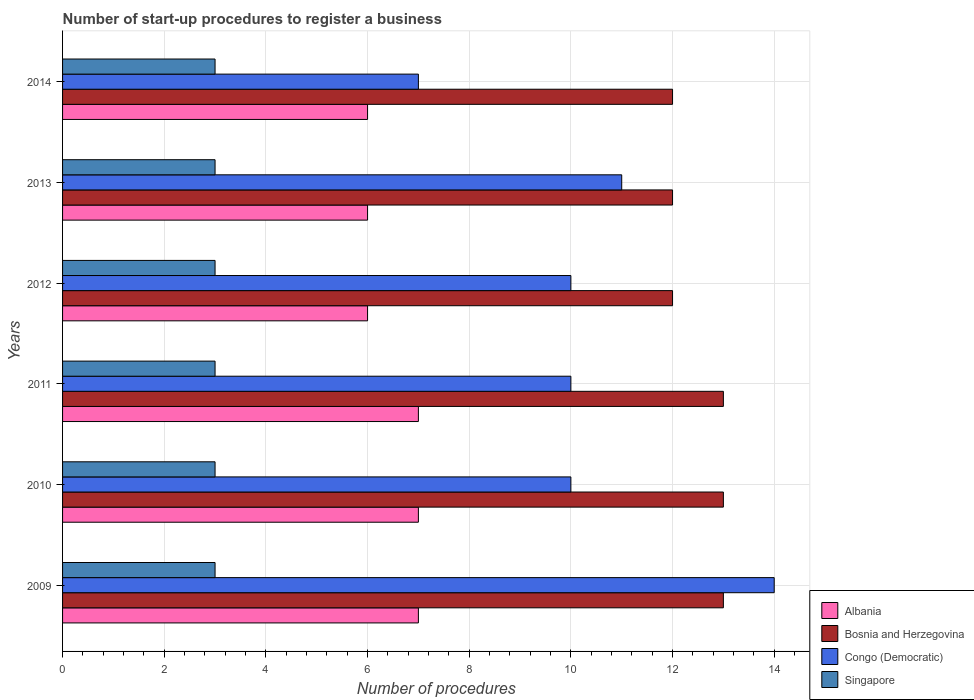How many groups of bars are there?
Provide a succinct answer. 6. Are the number of bars per tick equal to the number of legend labels?
Offer a very short reply. Yes. Are the number of bars on each tick of the Y-axis equal?
Offer a terse response. Yes. What is the number of procedures required to register a business in Bosnia and Herzegovina in 2014?
Offer a very short reply. 12. Across all years, what is the maximum number of procedures required to register a business in Congo (Democratic)?
Provide a short and direct response. 14. Across all years, what is the minimum number of procedures required to register a business in Bosnia and Herzegovina?
Give a very brief answer. 12. In which year was the number of procedures required to register a business in Congo (Democratic) maximum?
Make the answer very short. 2009. What is the total number of procedures required to register a business in Albania in the graph?
Ensure brevity in your answer.  39. What is the difference between the number of procedures required to register a business in Bosnia and Herzegovina in 2010 and the number of procedures required to register a business in Albania in 2012?
Keep it short and to the point. 7. What is the average number of procedures required to register a business in Bosnia and Herzegovina per year?
Provide a short and direct response. 12.5. In the year 2012, what is the difference between the number of procedures required to register a business in Bosnia and Herzegovina and number of procedures required to register a business in Congo (Democratic)?
Your answer should be very brief. 2. What is the ratio of the number of procedures required to register a business in Bosnia and Herzegovina in 2011 to that in 2012?
Give a very brief answer. 1.08. Is the number of procedures required to register a business in Singapore in 2011 less than that in 2013?
Ensure brevity in your answer.  No. Is the difference between the number of procedures required to register a business in Bosnia and Herzegovina in 2009 and 2013 greater than the difference between the number of procedures required to register a business in Congo (Democratic) in 2009 and 2013?
Your answer should be very brief. No. What is the difference between the highest and the second highest number of procedures required to register a business in Singapore?
Provide a short and direct response. 0. What is the difference between the highest and the lowest number of procedures required to register a business in Albania?
Make the answer very short. 1. What does the 3rd bar from the top in 2014 represents?
Provide a succinct answer. Bosnia and Herzegovina. What does the 1st bar from the bottom in 2014 represents?
Offer a very short reply. Albania. Is it the case that in every year, the sum of the number of procedures required to register a business in Bosnia and Herzegovina and number of procedures required to register a business in Singapore is greater than the number of procedures required to register a business in Congo (Democratic)?
Your answer should be very brief. Yes. Are all the bars in the graph horizontal?
Provide a succinct answer. Yes. Are the values on the major ticks of X-axis written in scientific E-notation?
Provide a succinct answer. No. Does the graph contain grids?
Make the answer very short. Yes. How many legend labels are there?
Give a very brief answer. 4. What is the title of the graph?
Ensure brevity in your answer.  Number of start-up procedures to register a business. Does "Puerto Rico" appear as one of the legend labels in the graph?
Offer a very short reply. No. What is the label or title of the X-axis?
Give a very brief answer. Number of procedures. What is the label or title of the Y-axis?
Offer a terse response. Years. What is the Number of procedures in Albania in 2009?
Keep it short and to the point. 7. What is the Number of procedures in Bosnia and Herzegovina in 2009?
Keep it short and to the point. 13. What is the Number of procedures in Singapore in 2009?
Your response must be concise. 3. What is the Number of procedures in Albania in 2010?
Your answer should be very brief. 7. What is the Number of procedures of Congo (Democratic) in 2010?
Provide a short and direct response. 10. What is the Number of procedures of Singapore in 2010?
Your answer should be compact. 3. What is the Number of procedures in Albania in 2012?
Keep it short and to the point. 6. What is the Number of procedures in Singapore in 2012?
Offer a very short reply. 3. What is the Number of procedures in Albania in 2013?
Provide a succinct answer. 6. What is the Number of procedures in Congo (Democratic) in 2013?
Give a very brief answer. 11. What is the Number of procedures in Singapore in 2013?
Your response must be concise. 3. What is the Number of procedures in Singapore in 2014?
Offer a terse response. 3. Across all years, what is the maximum Number of procedures in Albania?
Keep it short and to the point. 7. Across all years, what is the maximum Number of procedures in Bosnia and Herzegovina?
Your answer should be very brief. 13. Across all years, what is the maximum Number of procedures of Congo (Democratic)?
Your answer should be compact. 14. Across all years, what is the minimum Number of procedures of Congo (Democratic)?
Give a very brief answer. 7. What is the total Number of procedures of Albania in the graph?
Make the answer very short. 39. What is the total Number of procedures of Bosnia and Herzegovina in the graph?
Provide a succinct answer. 75. What is the difference between the Number of procedures in Albania in 2009 and that in 2010?
Ensure brevity in your answer.  0. What is the difference between the Number of procedures in Congo (Democratic) in 2009 and that in 2010?
Make the answer very short. 4. What is the difference between the Number of procedures in Singapore in 2009 and that in 2010?
Offer a terse response. 0. What is the difference between the Number of procedures of Bosnia and Herzegovina in 2009 and that in 2011?
Provide a short and direct response. 0. What is the difference between the Number of procedures of Singapore in 2009 and that in 2011?
Offer a terse response. 0. What is the difference between the Number of procedures in Albania in 2009 and that in 2012?
Make the answer very short. 1. What is the difference between the Number of procedures in Congo (Democratic) in 2009 and that in 2013?
Make the answer very short. 3. What is the difference between the Number of procedures of Singapore in 2009 and that in 2013?
Your answer should be very brief. 0. What is the difference between the Number of procedures of Congo (Democratic) in 2009 and that in 2014?
Offer a terse response. 7. What is the difference between the Number of procedures of Singapore in 2009 and that in 2014?
Offer a terse response. 0. What is the difference between the Number of procedures in Albania in 2010 and that in 2011?
Ensure brevity in your answer.  0. What is the difference between the Number of procedures of Congo (Democratic) in 2010 and that in 2011?
Offer a very short reply. 0. What is the difference between the Number of procedures in Singapore in 2010 and that in 2011?
Ensure brevity in your answer.  0. What is the difference between the Number of procedures in Bosnia and Herzegovina in 2010 and that in 2012?
Give a very brief answer. 1. What is the difference between the Number of procedures in Albania in 2010 and that in 2013?
Provide a succinct answer. 1. What is the difference between the Number of procedures of Bosnia and Herzegovina in 2010 and that in 2013?
Your answer should be compact. 1. What is the difference between the Number of procedures of Albania in 2010 and that in 2014?
Offer a very short reply. 1. What is the difference between the Number of procedures of Bosnia and Herzegovina in 2010 and that in 2014?
Provide a succinct answer. 1. What is the difference between the Number of procedures in Singapore in 2010 and that in 2014?
Offer a terse response. 0. What is the difference between the Number of procedures in Bosnia and Herzegovina in 2011 and that in 2012?
Ensure brevity in your answer.  1. What is the difference between the Number of procedures of Congo (Democratic) in 2011 and that in 2012?
Keep it short and to the point. 0. What is the difference between the Number of procedures in Singapore in 2011 and that in 2012?
Keep it short and to the point. 0. What is the difference between the Number of procedures of Bosnia and Herzegovina in 2011 and that in 2013?
Offer a terse response. 1. What is the difference between the Number of procedures in Singapore in 2011 and that in 2013?
Give a very brief answer. 0. What is the difference between the Number of procedures of Albania in 2011 and that in 2014?
Your answer should be very brief. 1. What is the difference between the Number of procedures of Singapore in 2011 and that in 2014?
Make the answer very short. 0. What is the difference between the Number of procedures of Bosnia and Herzegovina in 2012 and that in 2013?
Make the answer very short. 0. What is the difference between the Number of procedures in Congo (Democratic) in 2012 and that in 2013?
Your response must be concise. -1. What is the difference between the Number of procedures of Singapore in 2012 and that in 2013?
Offer a terse response. 0. What is the difference between the Number of procedures of Albania in 2012 and that in 2014?
Your answer should be very brief. 0. What is the difference between the Number of procedures of Bosnia and Herzegovina in 2013 and that in 2014?
Provide a succinct answer. 0. What is the difference between the Number of procedures in Singapore in 2013 and that in 2014?
Your answer should be compact. 0. What is the difference between the Number of procedures of Albania in 2009 and the Number of procedures of Bosnia and Herzegovina in 2010?
Your response must be concise. -6. What is the difference between the Number of procedures in Bosnia and Herzegovina in 2009 and the Number of procedures in Congo (Democratic) in 2010?
Offer a very short reply. 3. What is the difference between the Number of procedures in Bosnia and Herzegovina in 2009 and the Number of procedures in Singapore in 2010?
Your response must be concise. 10. What is the difference between the Number of procedures of Congo (Democratic) in 2009 and the Number of procedures of Singapore in 2010?
Offer a very short reply. 11. What is the difference between the Number of procedures of Albania in 2009 and the Number of procedures of Bosnia and Herzegovina in 2011?
Give a very brief answer. -6. What is the difference between the Number of procedures in Bosnia and Herzegovina in 2009 and the Number of procedures in Congo (Democratic) in 2011?
Offer a very short reply. 3. What is the difference between the Number of procedures of Albania in 2009 and the Number of procedures of Singapore in 2012?
Offer a very short reply. 4. What is the difference between the Number of procedures of Bosnia and Herzegovina in 2009 and the Number of procedures of Congo (Democratic) in 2012?
Ensure brevity in your answer.  3. What is the difference between the Number of procedures in Congo (Democratic) in 2009 and the Number of procedures in Singapore in 2012?
Make the answer very short. 11. What is the difference between the Number of procedures of Albania in 2009 and the Number of procedures of Bosnia and Herzegovina in 2013?
Provide a short and direct response. -5. What is the difference between the Number of procedures of Albania in 2009 and the Number of procedures of Singapore in 2013?
Offer a terse response. 4. What is the difference between the Number of procedures in Bosnia and Herzegovina in 2009 and the Number of procedures in Singapore in 2013?
Keep it short and to the point. 10. What is the difference between the Number of procedures in Albania in 2009 and the Number of procedures in Bosnia and Herzegovina in 2014?
Your answer should be very brief. -5. What is the difference between the Number of procedures of Albania in 2009 and the Number of procedures of Congo (Democratic) in 2014?
Make the answer very short. 0. What is the difference between the Number of procedures in Albania in 2009 and the Number of procedures in Singapore in 2014?
Ensure brevity in your answer.  4. What is the difference between the Number of procedures of Albania in 2010 and the Number of procedures of Bosnia and Herzegovina in 2011?
Keep it short and to the point. -6. What is the difference between the Number of procedures of Albania in 2010 and the Number of procedures of Congo (Democratic) in 2011?
Your answer should be very brief. -3. What is the difference between the Number of procedures of Congo (Democratic) in 2010 and the Number of procedures of Singapore in 2011?
Offer a very short reply. 7. What is the difference between the Number of procedures of Albania in 2010 and the Number of procedures of Singapore in 2012?
Give a very brief answer. 4. What is the difference between the Number of procedures of Bosnia and Herzegovina in 2010 and the Number of procedures of Congo (Democratic) in 2012?
Your answer should be very brief. 3. What is the difference between the Number of procedures of Bosnia and Herzegovina in 2010 and the Number of procedures of Singapore in 2012?
Your response must be concise. 10. What is the difference between the Number of procedures of Congo (Democratic) in 2010 and the Number of procedures of Singapore in 2012?
Your answer should be very brief. 7. What is the difference between the Number of procedures in Albania in 2010 and the Number of procedures in Congo (Democratic) in 2013?
Provide a succinct answer. -4. What is the difference between the Number of procedures in Albania in 2010 and the Number of procedures in Singapore in 2013?
Keep it short and to the point. 4. What is the difference between the Number of procedures in Bosnia and Herzegovina in 2010 and the Number of procedures in Congo (Democratic) in 2013?
Make the answer very short. 2. What is the difference between the Number of procedures of Albania in 2010 and the Number of procedures of Singapore in 2014?
Your answer should be very brief. 4. What is the difference between the Number of procedures of Bosnia and Herzegovina in 2010 and the Number of procedures of Congo (Democratic) in 2014?
Make the answer very short. 6. What is the difference between the Number of procedures in Congo (Democratic) in 2010 and the Number of procedures in Singapore in 2014?
Make the answer very short. 7. What is the difference between the Number of procedures of Albania in 2011 and the Number of procedures of Congo (Democratic) in 2012?
Give a very brief answer. -3. What is the difference between the Number of procedures of Bosnia and Herzegovina in 2011 and the Number of procedures of Congo (Democratic) in 2012?
Keep it short and to the point. 3. What is the difference between the Number of procedures of Albania in 2011 and the Number of procedures of Singapore in 2013?
Offer a terse response. 4. What is the difference between the Number of procedures of Albania in 2011 and the Number of procedures of Bosnia and Herzegovina in 2014?
Keep it short and to the point. -5. What is the difference between the Number of procedures of Bosnia and Herzegovina in 2011 and the Number of procedures of Singapore in 2014?
Your response must be concise. 10. What is the difference between the Number of procedures of Congo (Democratic) in 2011 and the Number of procedures of Singapore in 2014?
Your response must be concise. 7. What is the difference between the Number of procedures in Albania in 2012 and the Number of procedures in Bosnia and Herzegovina in 2013?
Ensure brevity in your answer.  -6. What is the difference between the Number of procedures of Albania in 2012 and the Number of procedures of Congo (Democratic) in 2013?
Keep it short and to the point. -5. What is the difference between the Number of procedures of Albania in 2012 and the Number of procedures of Singapore in 2013?
Keep it short and to the point. 3. What is the difference between the Number of procedures in Bosnia and Herzegovina in 2012 and the Number of procedures in Congo (Democratic) in 2013?
Your answer should be very brief. 1. What is the difference between the Number of procedures in Albania in 2012 and the Number of procedures in Bosnia and Herzegovina in 2014?
Offer a terse response. -6. What is the difference between the Number of procedures in Albania in 2012 and the Number of procedures in Congo (Democratic) in 2014?
Provide a short and direct response. -1. What is the difference between the Number of procedures in Congo (Democratic) in 2012 and the Number of procedures in Singapore in 2014?
Give a very brief answer. 7. What is the difference between the Number of procedures in Albania in 2013 and the Number of procedures in Bosnia and Herzegovina in 2014?
Ensure brevity in your answer.  -6. What is the difference between the Number of procedures in Albania in 2013 and the Number of procedures in Congo (Democratic) in 2014?
Provide a short and direct response. -1. What is the average Number of procedures of Albania per year?
Provide a short and direct response. 6.5. What is the average Number of procedures of Congo (Democratic) per year?
Offer a very short reply. 10.33. What is the average Number of procedures of Singapore per year?
Keep it short and to the point. 3. In the year 2009, what is the difference between the Number of procedures of Albania and Number of procedures of Bosnia and Herzegovina?
Your answer should be compact. -6. In the year 2009, what is the difference between the Number of procedures of Albania and Number of procedures of Singapore?
Provide a succinct answer. 4. In the year 2009, what is the difference between the Number of procedures in Bosnia and Herzegovina and Number of procedures in Singapore?
Give a very brief answer. 10. In the year 2010, what is the difference between the Number of procedures in Albania and Number of procedures in Bosnia and Herzegovina?
Provide a short and direct response. -6. In the year 2010, what is the difference between the Number of procedures of Bosnia and Herzegovina and Number of procedures of Congo (Democratic)?
Offer a very short reply. 3. In the year 2010, what is the difference between the Number of procedures of Bosnia and Herzegovina and Number of procedures of Singapore?
Offer a terse response. 10. In the year 2010, what is the difference between the Number of procedures of Congo (Democratic) and Number of procedures of Singapore?
Your answer should be compact. 7. In the year 2011, what is the difference between the Number of procedures in Albania and Number of procedures in Bosnia and Herzegovina?
Keep it short and to the point. -6. In the year 2011, what is the difference between the Number of procedures of Albania and Number of procedures of Congo (Democratic)?
Provide a succinct answer. -3. In the year 2011, what is the difference between the Number of procedures in Congo (Democratic) and Number of procedures in Singapore?
Provide a short and direct response. 7. In the year 2012, what is the difference between the Number of procedures in Bosnia and Herzegovina and Number of procedures in Congo (Democratic)?
Offer a terse response. 2. In the year 2012, what is the difference between the Number of procedures in Bosnia and Herzegovina and Number of procedures in Singapore?
Ensure brevity in your answer.  9. In the year 2012, what is the difference between the Number of procedures in Congo (Democratic) and Number of procedures in Singapore?
Your answer should be compact. 7. In the year 2013, what is the difference between the Number of procedures in Albania and Number of procedures in Congo (Democratic)?
Provide a succinct answer. -5. In the year 2013, what is the difference between the Number of procedures of Albania and Number of procedures of Singapore?
Provide a short and direct response. 3. In the year 2013, what is the difference between the Number of procedures in Bosnia and Herzegovina and Number of procedures in Congo (Democratic)?
Give a very brief answer. 1. In the year 2014, what is the difference between the Number of procedures in Albania and Number of procedures in Bosnia and Herzegovina?
Keep it short and to the point. -6. In the year 2014, what is the difference between the Number of procedures of Albania and Number of procedures of Congo (Democratic)?
Provide a short and direct response. -1. In the year 2014, what is the difference between the Number of procedures in Albania and Number of procedures in Singapore?
Give a very brief answer. 3. In the year 2014, what is the difference between the Number of procedures of Bosnia and Herzegovina and Number of procedures of Congo (Democratic)?
Offer a very short reply. 5. In the year 2014, what is the difference between the Number of procedures of Bosnia and Herzegovina and Number of procedures of Singapore?
Provide a succinct answer. 9. What is the ratio of the Number of procedures in Albania in 2009 to that in 2010?
Keep it short and to the point. 1. What is the ratio of the Number of procedures in Bosnia and Herzegovina in 2009 to that in 2011?
Provide a succinct answer. 1. What is the ratio of the Number of procedures in Albania in 2009 to that in 2012?
Offer a very short reply. 1.17. What is the ratio of the Number of procedures of Bosnia and Herzegovina in 2009 to that in 2012?
Make the answer very short. 1.08. What is the ratio of the Number of procedures in Congo (Democratic) in 2009 to that in 2012?
Make the answer very short. 1.4. What is the ratio of the Number of procedures of Albania in 2009 to that in 2013?
Keep it short and to the point. 1.17. What is the ratio of the Number of procedures in Bosnia and Herzegovina in 2009 to that in 2013?
Offer a very short reply. 1.08. What is the ratio of the Number of procedures of Congo (Democratic) in 2009 to that in 2013?
Offer a terse response. 1.27. What is the ratio of the Number of procedures of Singapore in 2009 to that in 2013?
Provide a short and direct response. 1. What is the ratio of the Number of procedures in Congo (Democratic) in 2009 to that in 2014?
Your response must be concise. 2. What is the ratio of the Number of procedures of Singapore in 2009 to that in 2014?
Your answer should be compact. 1. What is the ratio of the Number of procedures in Albania in 2010 to that in 2011?
Make the answer very short. 1. What is the ratio of the Number of procedures of Bosnia and Herzegovina in 2010 to that in 2011?
Your answer should be compact. 1. What is the ratio of the Number of procedures in Albania in 2010 to that in 2013?
Your response must be concise. 1.17. What is the ratio of the Number of procedures of Bosnia and Herzegovina in 2010 to that in 2014?
Your answer should be compact. 1.08. What is the ratio of the Number of procedures in Congo (Democratic) in 2010 to that in 2014?
Provide a succinct answer. 1.43. What is the ratio of the Number of procedures of Bosnia and Herzegovina in 2011 to that in 2012?
Your response must be concise. 1.08. What is the ratio of the Number of procedures of Singapore in 2011 to that in 2012?
Your answer should be very brief. 1. What is the ratio of the Number of procedures in Albania in 2011 to that in 2013?
Your answer should be very brief. 1.17. What is the ratio of the Number of procedures of Bosnia and Herzegovina in 2011 to that in 2013?
Ensure brevity in your answer.  1.08. What is the ratio of the Number of procedures in Bosnia and Herzegovina in 2011 to that in 2014?
Offer a terse response. 1.08. What is the ratio of the Number of procedures in Congo (Democratic) in 2011 to that in 2014?
Keep it short and to the point. 1.43. What is the ratio of the Number of procedures of Singapore in 2011 to that in 2014?
Provide a succinct answer. 1. What is the ratio of the Number of procedures of Bosnia and Herzegovina in 2012 to that in 2013?
Offer a very short reply. 1. What is the ratio of the Number of procedures of Congo (Democratic) in 2012 to that in 2013?
Your response must be concise. 0.91. What is the ratio of the Number of procedures in Singapore in 2012 to that in 2013?
Your answer should be very brief. 1. What is the ratio of the Number of procedures of Albania in 2012 to that in 2014?
Your response must be concise. 1. What is the ratio of the Number of procedures in Congo (Democratic) in 2012 to that in 2014?
Make the answer very short. 1.43. What is the ratio of the Number of procedures of Congo (Democratic) in 2013 to that in 2014?
Ensure brevity in your answer.  1.57. What is the ratio of the Number of procedures in Singapore in 2013 to that in 2014?
Ensure brevity in your answer.  1. What is the difference between the highest and the lowest Number of procedures of Bosnia and Herzegovina?
Provide a succinct answer. 1. What is the difference between the highest and the lowest Number of procedures of Congo (Democratic)?
Offer a terse response. 7. What is the difference between the highest and the lowest Number of procedures of Singapore?
Provide a succinct answer. 0. 